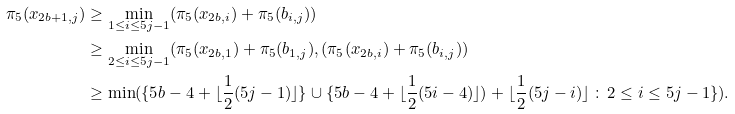Convert formula to latex. <formula><loc_0><loc_0><loc_500><loc_500>\pi _ { 5 } ( x _ { 2 b + 1 , j } ) & \geq \min _ { 1 \leq i \leq 5 j - 1 } ( \pi _ { 5 } ( x _ { 2 b , i } ) + \pi _ { 5 } ( b _ { i , j } ) ) \\ & \geq \min _ { 2 \leq i \leq 5 j - 1 } ( \pi _ { 5 } ( x _ { 2 b , 1 } ) + \pi _ { 5 } ( b _ { 1 , j } ) , ( \pi _ { 5 } ( x _ { 2 b , i } ) + \pi _ { 5 } ( b _ { i , j } ) ) \\ & \geq \min ( \{ 5 b - 4 + \lfloor \frac { 1 } { 2 } ( 5 j - 1 ) \rfloor \} \cup \{ 5 b - 4 + \lfloor \frac { 1 } { 2 } ( 5 i - 4 ) \rfloor ) + \lfloor \frac { 1 } { 2 } ( 5 j - i ) \rfloor \, \colon \, 2 \leq i \leq 5 j - 1 \} ) .</formula> 